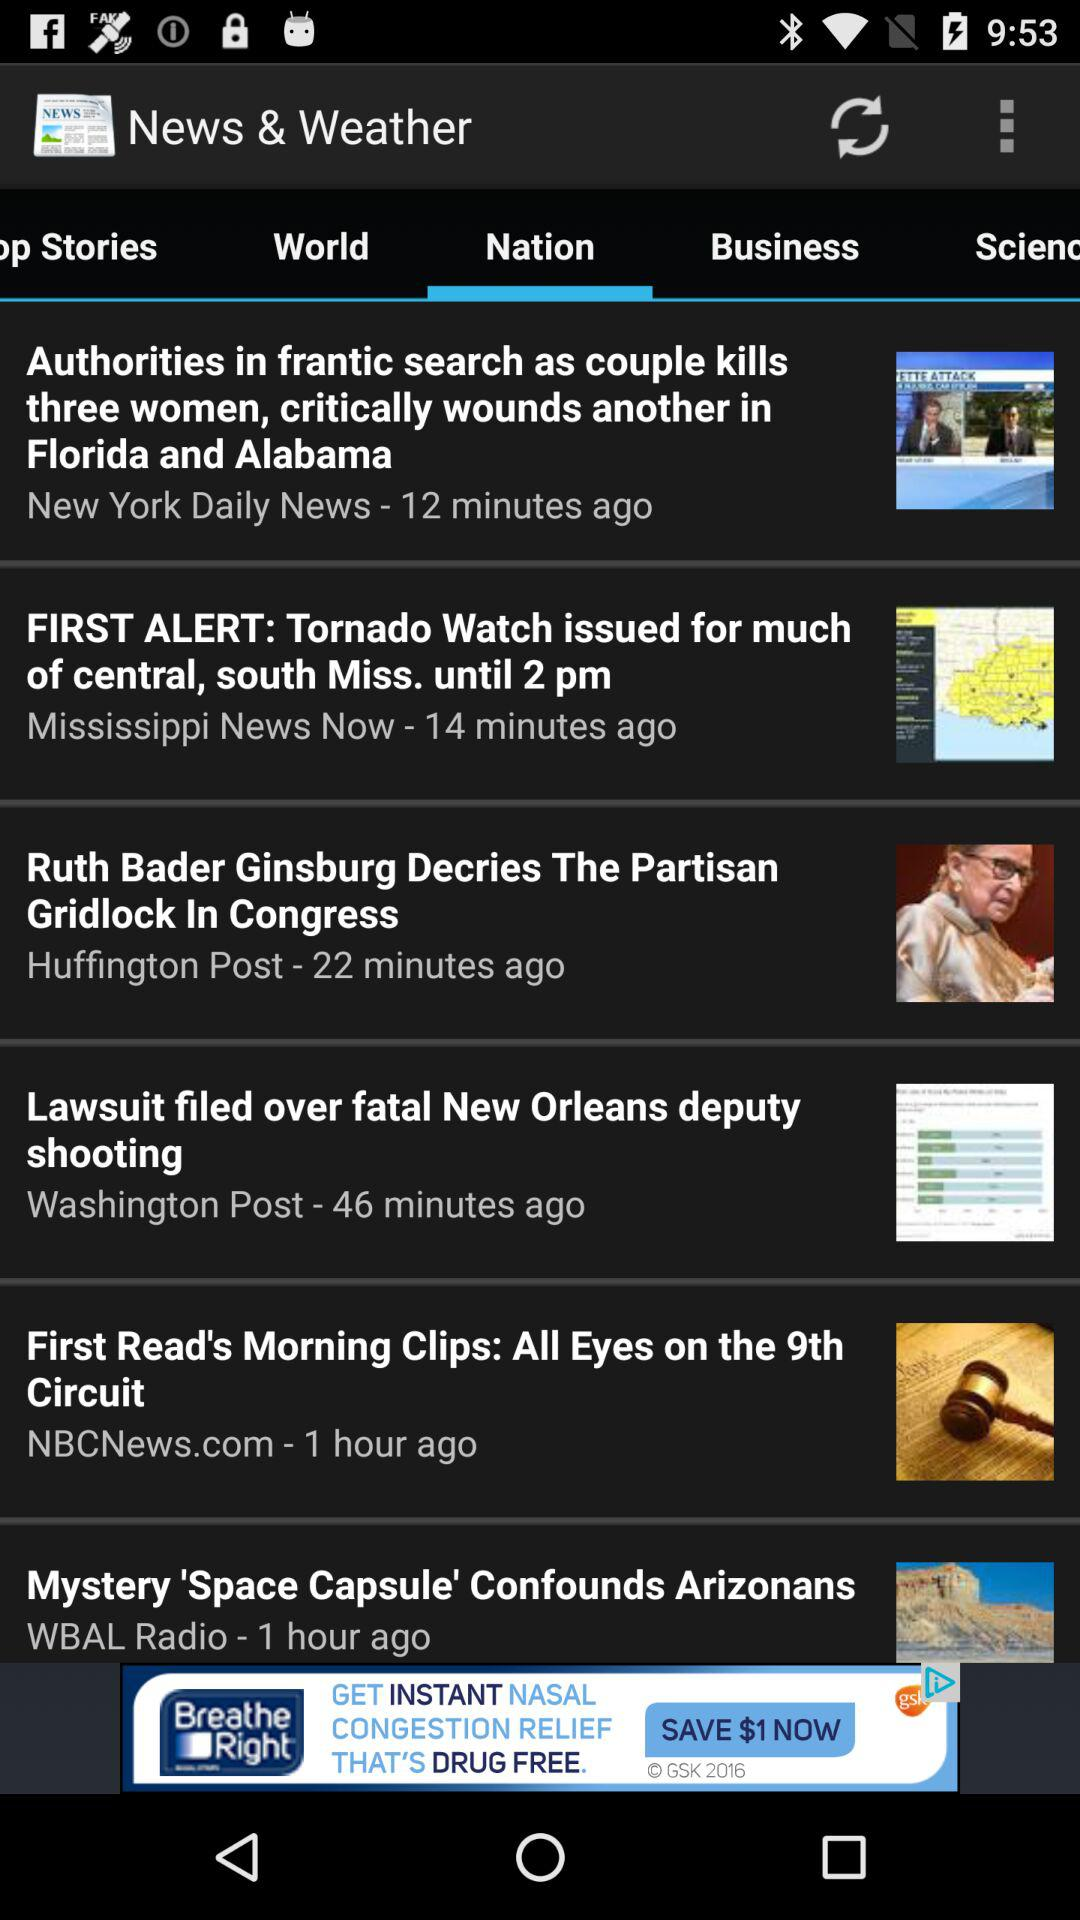How long ago was the news "Mystery 'Space Capsule' Confounds Arizonans" posted? The news "Mystery 'Space Capsule' Confounds Arizonans" was posted 1 hour ago. 